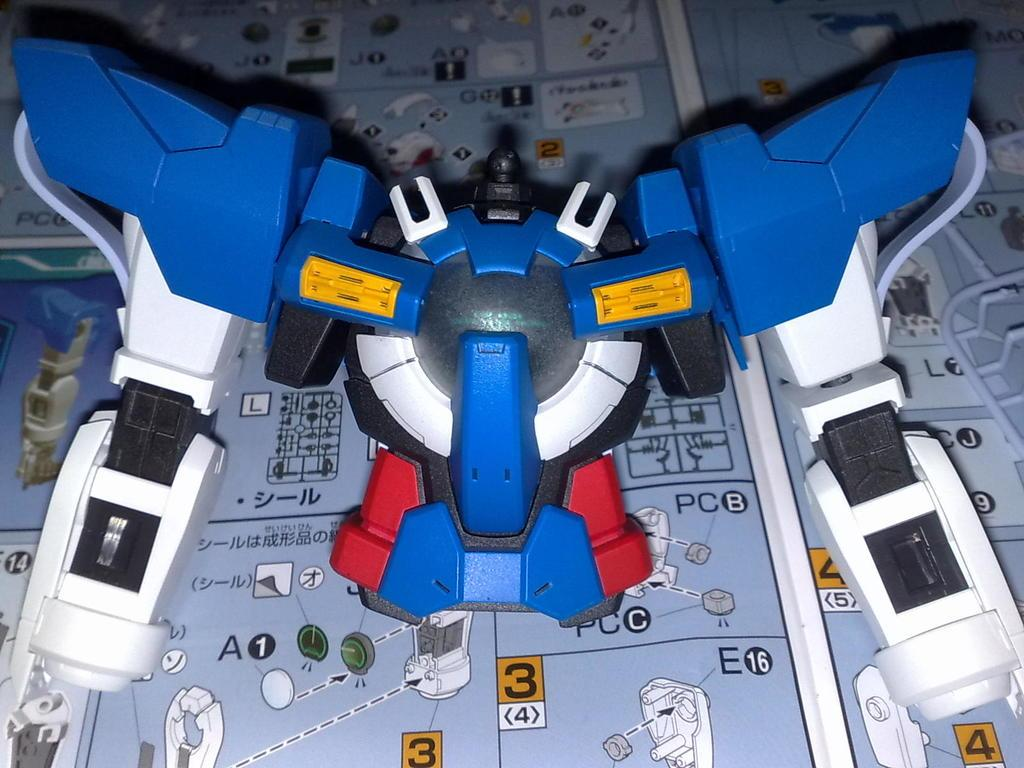What is the color of the object in the image? The object in the image is blue and white colored. What can be seen in the background of the image? There is writing visible in the background of the image. What type of education does the porter have in the image? There is no porter present in the image, so it is not possible to determine their level of education. 